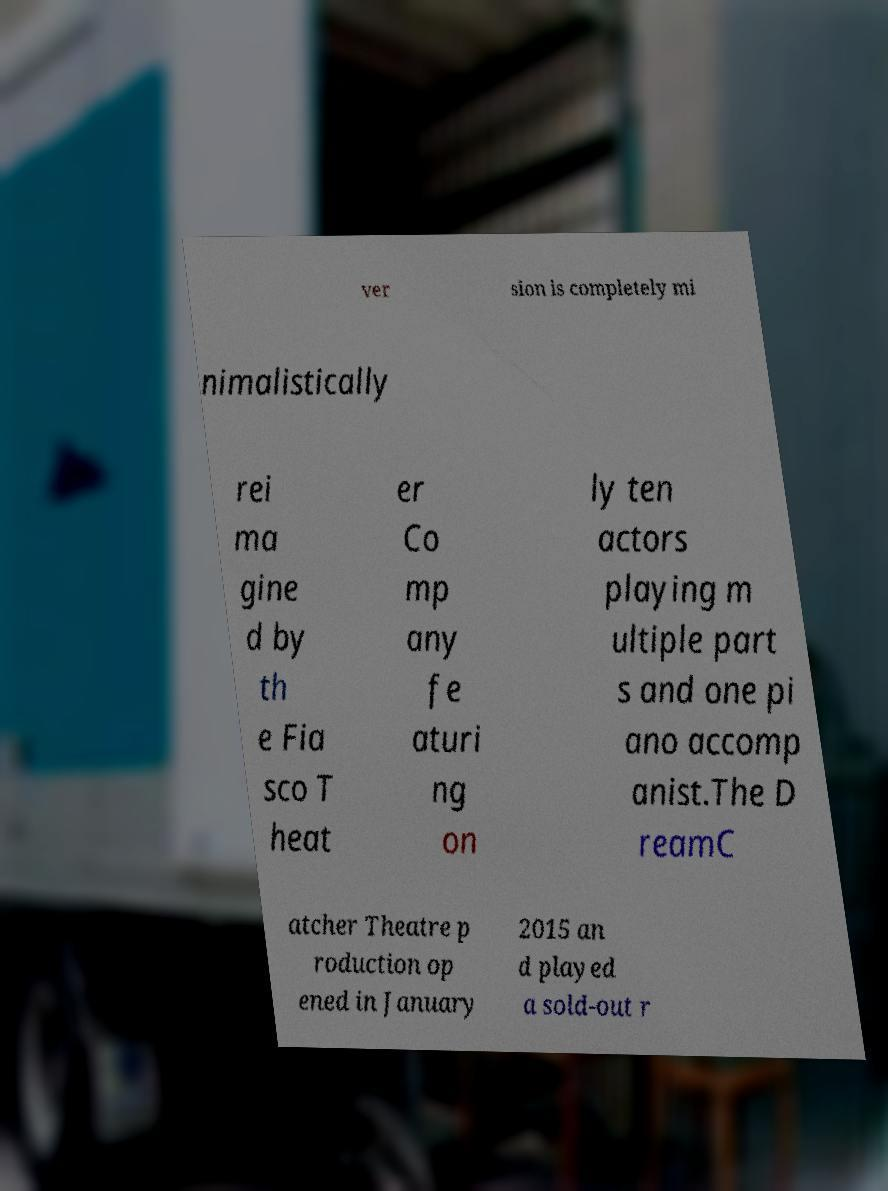Can you read and provide the text displayed in the image?This photo seems to have some interesting text. Can you extract and type it out for me? ver sion is completely mi nimalistically rei ma gine d by th e Fia sco T heat er Co mp any fe aturi ng on ly ten actors playing m ultiple part s and one pi ano accomp anist.The D reamC atcher Theatre p roduction op ened in January 2015 an d played a sold-out r 